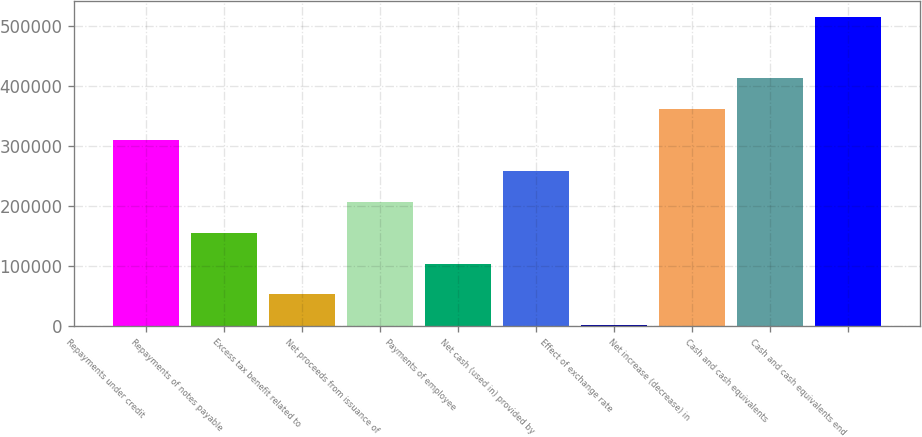<chart> <loc_0><loc_0><loc_500><loc_500><bar_chart><fcel>Repayments under credit<fcel>Repayments of notes payable<fcel>Excess tax benefit related to<fcel>Net proceeds from issuance of<fcel>Payments of employee<fcel>Net cash (used in) provided by<fcel>Effect of exchange rate<fcel>Net increase (decrease) in<fcel>Cash and cash equivalents<fcel>Cash and cash equivalents end<nl><fcel>309488<fcel>154885<fcel>51816.3<fcel>206419<fcel>103351<fcel>257954<fcel>282<fcel>361022<fcel>412556<fcel>515625<nl></chart> 